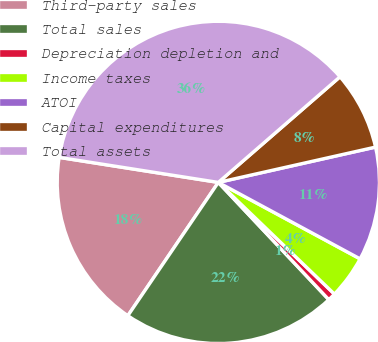Convert chart. <chart><loc_0><loc_0><loc_500><loc_500><pie_chart><fcel>Third-party sales<fcel>Total sales<fcel>Depreciation depletion and<fcel>Income taxes<fcel>ATOI<fcel>Capital expenditures<fcel>Total assets<nl><fcel>17.99%<fcel>21.52%<fcel>0.78%<fcel>4.32%<fcel>11.39%<fcel>7.86%<fcel>36.14%<nl></chart> 